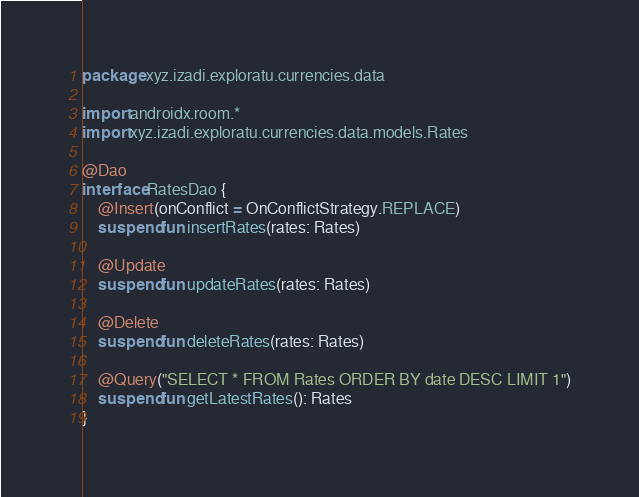<code> <loc_0><loc_0><loc_500><loc_500><_Kotlin_>package xyz.izadi.exploratu.currencies.data

import androidx.room.*
import xyz.izadi.exploratu.currencies.data.models.Rates

@Dao
interface RatesDao {
    @Insert(onConflict = OnConflictStrategy.REPLACE)
    suspend fun insertRates(rates: Rates)

    @Update
    suspend fun updateRates(rates: Rates)

    @Delete
    suspend fun deleteRates(rates: Rates)

    @Query("SELECT * FROM Rates ORDER BY date DESC LIMIT 1")
    suspend fun getLatestRates(): Rates
}</code> 